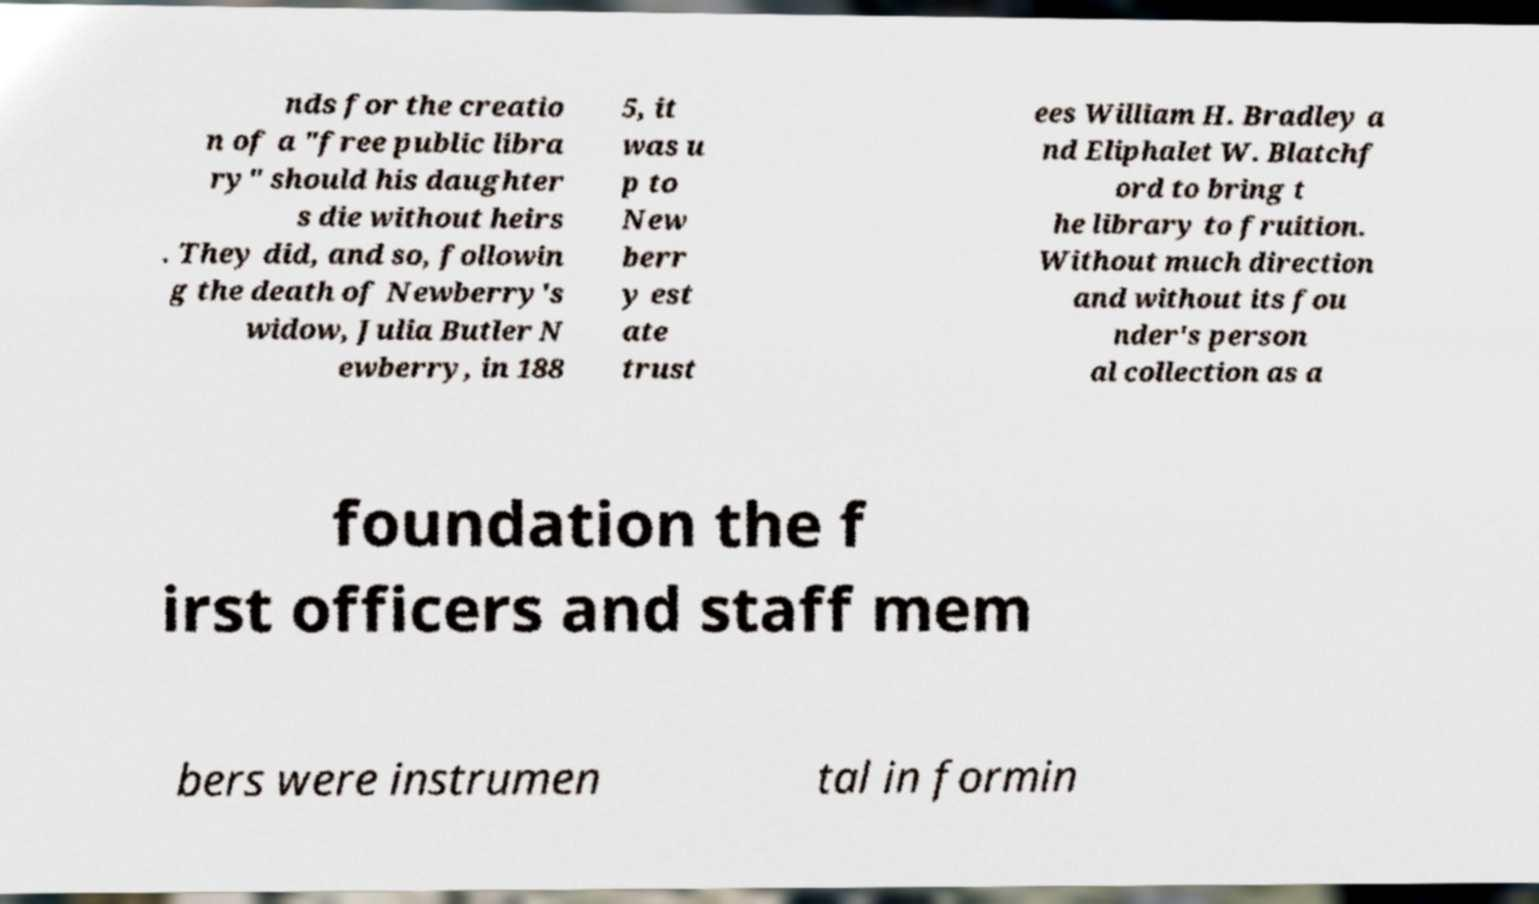There's text embedded in this image that I need extracted. Can you transcribe it verbatim? nds for the creatio n of a "free public libra ry" should his daughter s die without heirs . They did, and so, followin g the death of Newberry's widow, Julia Butler N ewberry, in 188 5, it was u p to New berr y est ate trust ees William H. Bradley a nd Eliphalet W. Blatchf ord to bring t he library to fruition. Without much direction and without its fou nder's person al collection as a foundation the f irst officers and staff mem bers were instrumen tal in formin 